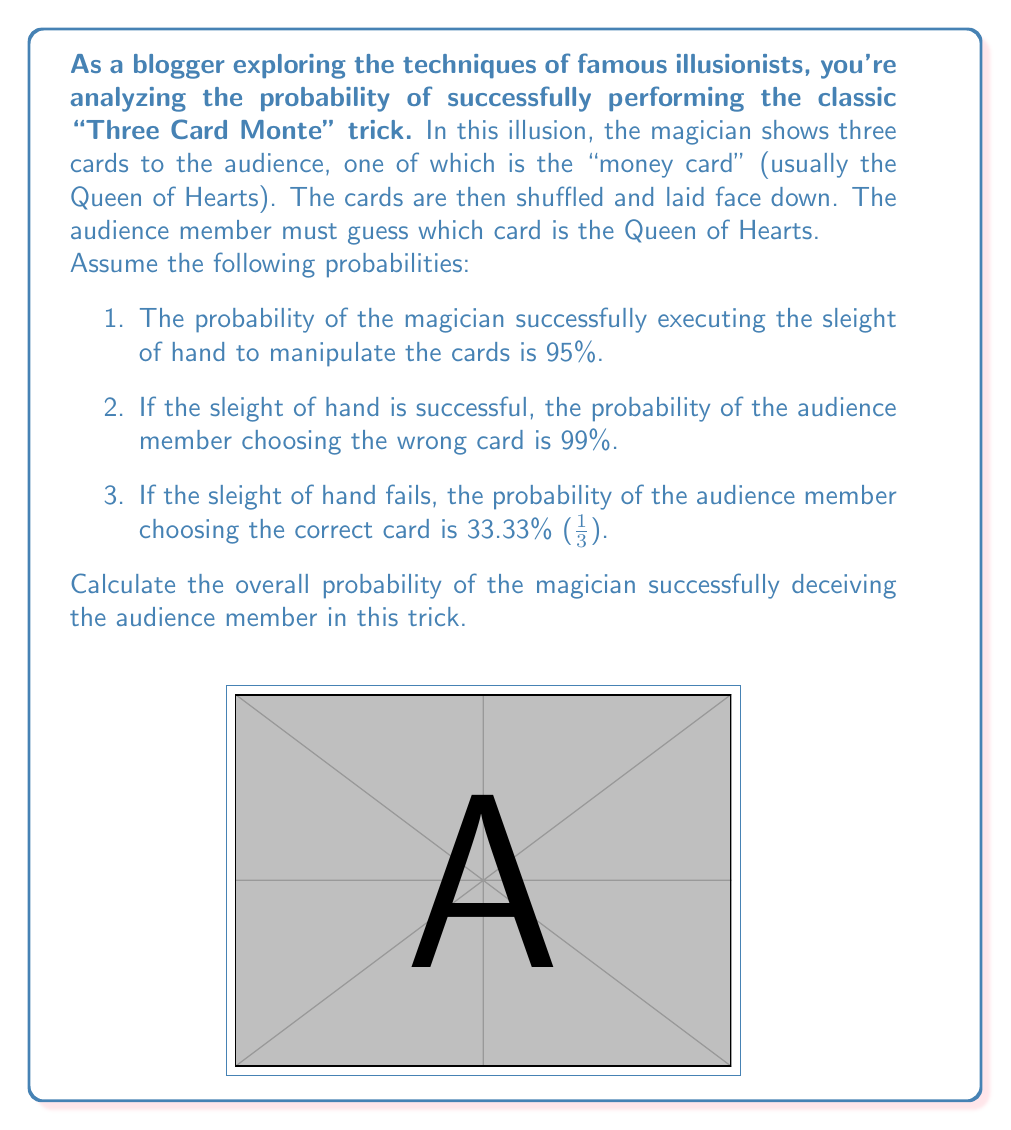Show me your answer to this math problem. Let's approach this problem step by step using the law of total probability:

1) Define events:
   A: The trick is successful (audience is deceived)
   S: Sleight of hand is successful
   F: Sleight of hand fails

2) Given probabilities:
   $P(S) = 0.95$
   $P(F) = 1 - P(S) = 0.05$
   $P(A|S) = 0.99$ (probability of audience being deceived given successful sleight of hand)
   $P(A|F) = 1 - \frac{1}{3} = \frac{2}{3}$ (probability of audience being deceived given failed sleight of hand)

3) Apply the law of total probability:
   $$P(A) = P(A|S) \cdot P(S) + P(A|F) \cdot P(F)$$

4) Substitute the values:
   $$P(A) = 0.99 \cdot 0.95 + \frac{2}{3} \cdot 0.05$$

5) Calculate:
   $$P(A) = 0.9405 + 0.0333 = 0.9738$$

6) Convert to percentage:
   $$P(A) = 97.38\%$$

Therefore, the overall probability of the magician successfully deceiving the audience member is 97.38%.
Answer: 97.38% 